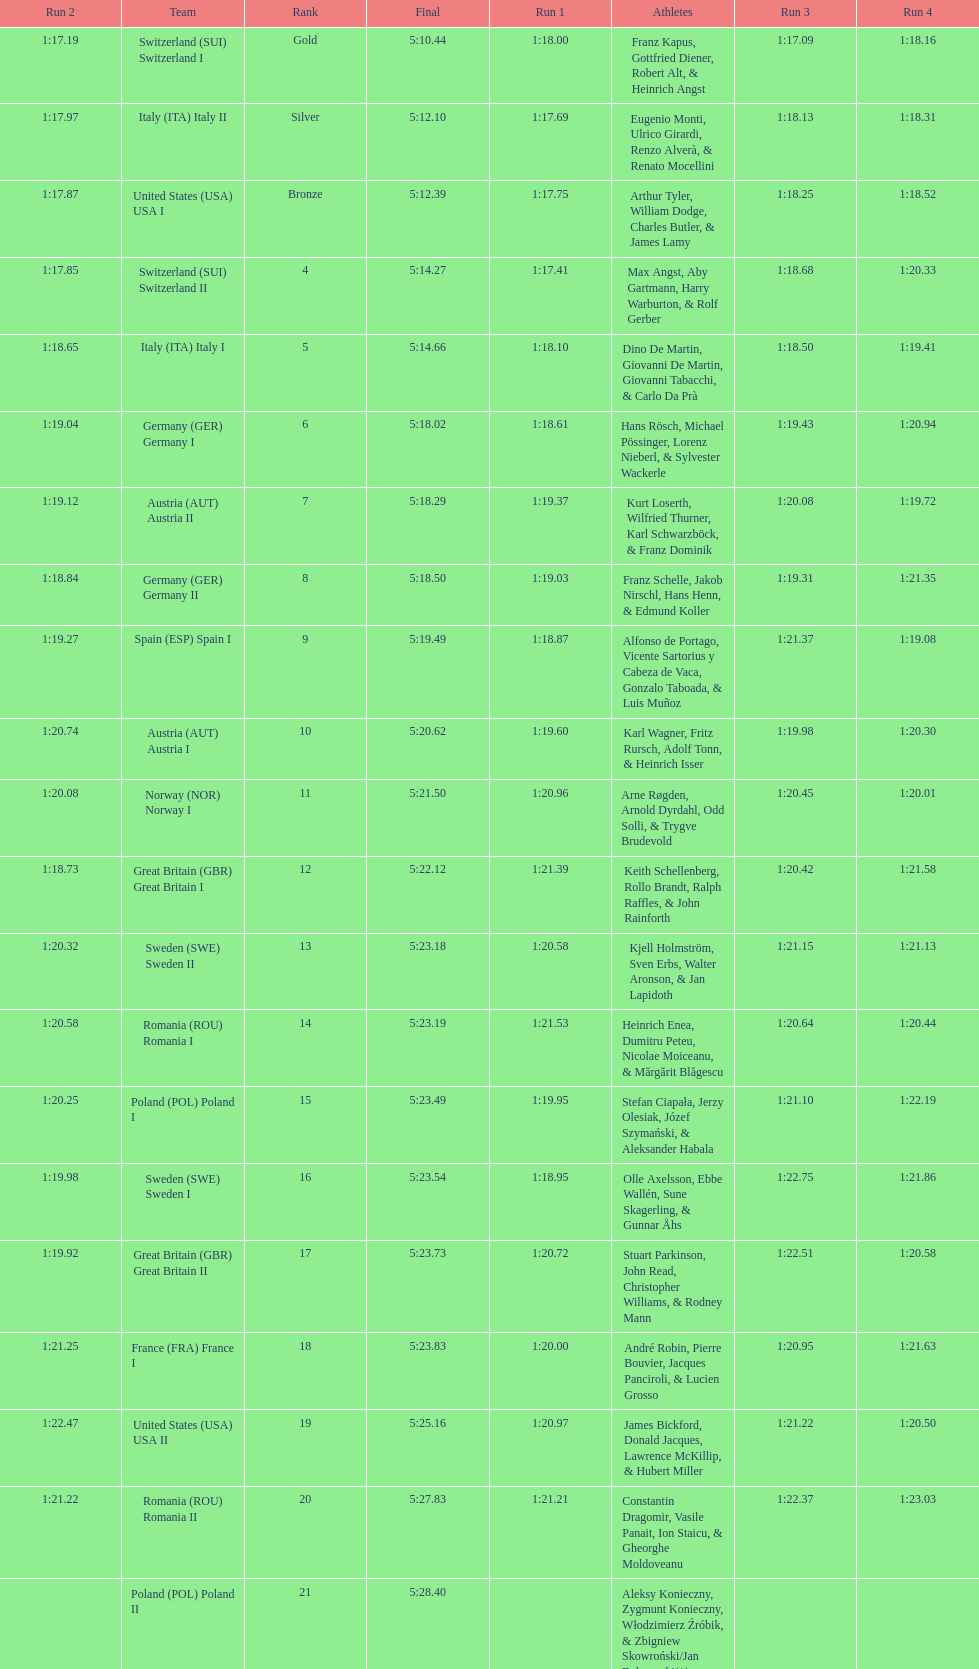Who is the previous team to italy (ita) italy ii? Switzerland (SUI) Switzerland I. 